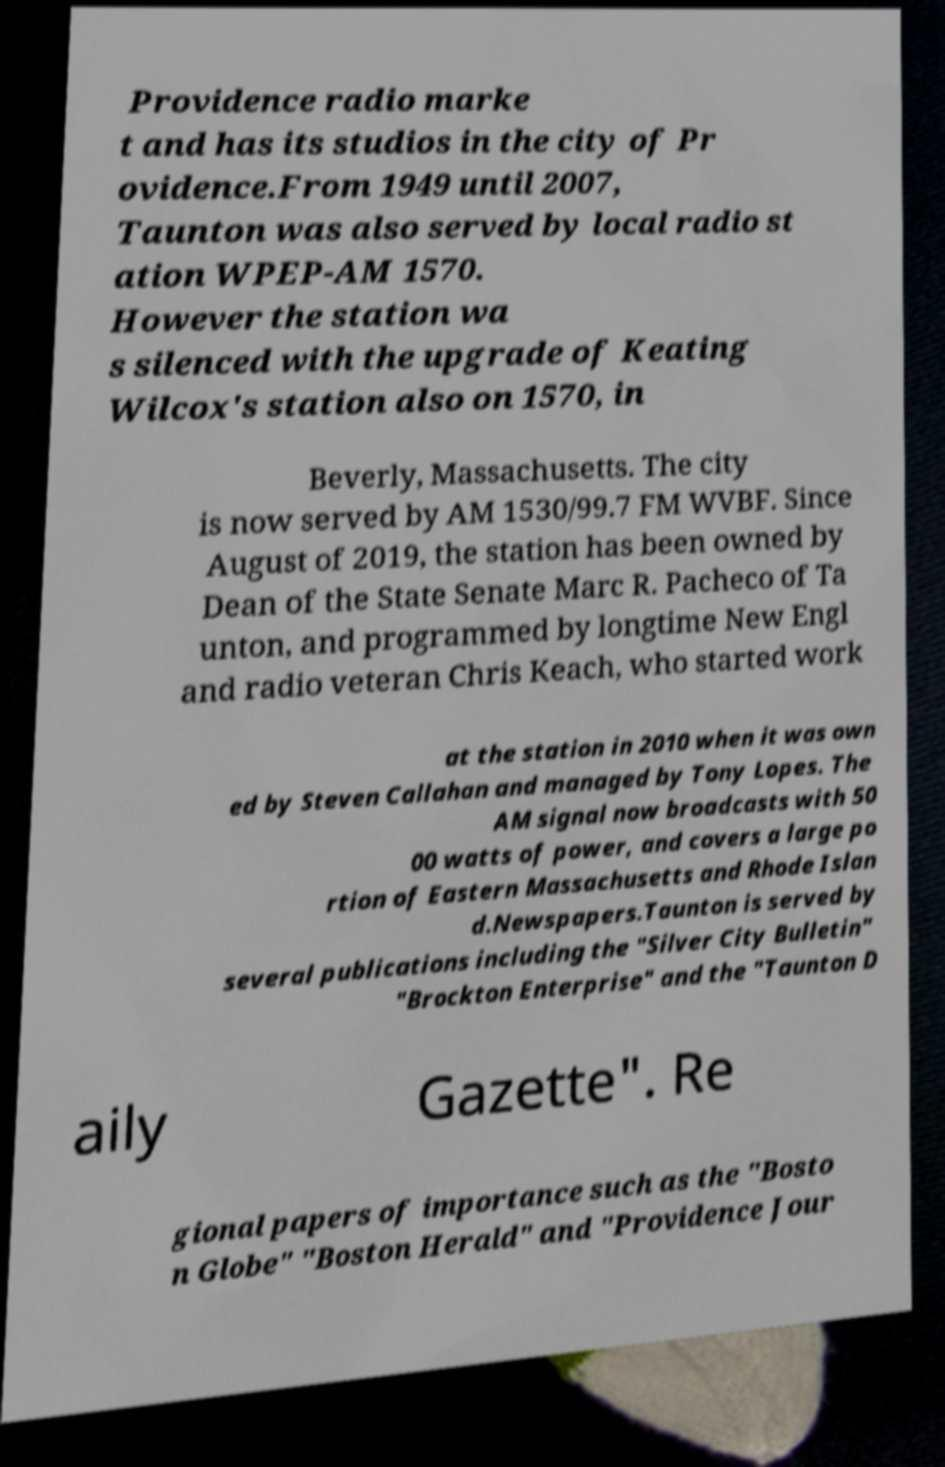Could you extract and type out the text from this image? Providence radio marke t and has its studios in the city of Pr ovidence.From 1949 until 2007, Taunton was also served by local radio st ation WPEP-AM 1570. However the station wa s silenced with the upgrade of Keating Wilcox's station also on 1570, in Beverly, Massachusetts. The city is now served by AM 1530/99.7 FM WVBF. Since August of 2019, the station has been owned by Dean of the State Senate Marc R. Pacheco of Ta unton, and programmed by longtime New Engl and radio veteran Chris Keach, who started work at the station in 2010 when it was own ed by Steven Callahan and managed by Tony Lopes. The AM signal now broadcasts with 50 00 watts of power, and covers a large po rtion of Eastern Massachusetts and Rhode Islan d.Newspapers.Taunton is served by several publications including the "Silver City Bulletin" "Brockton Enterprise" and the "Taunton D aily Gazette". Re gional papers of importance such as the "Bosto n Globe" "Boston Herald" and "Providence Jour 